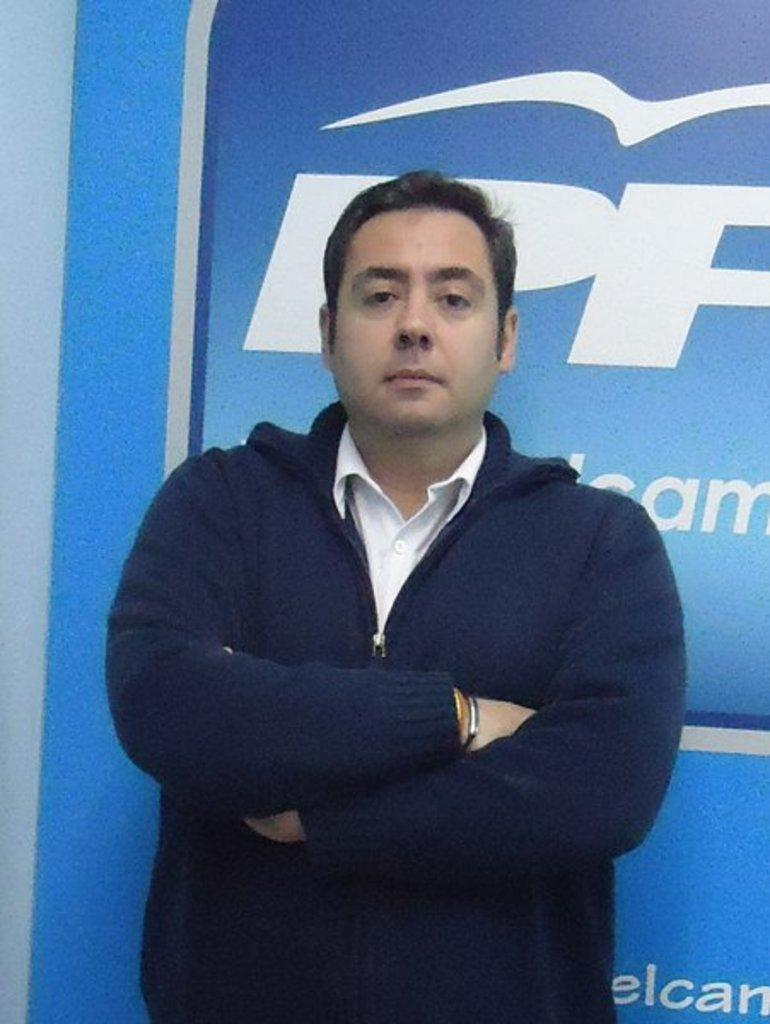What is the main subject of the image? The main subject of the image is a man standing. What is the man wearing in the image? The man is wearing clothes and a bracelet. What type of image is this? The image is a poster. What type of burst can be seen in the image? There is no burst present in the image. What type of earthquake can be seen in the image? There is no earthquake present in the image. What type of trucks can be seen in the image? There is no truck present in the image. 